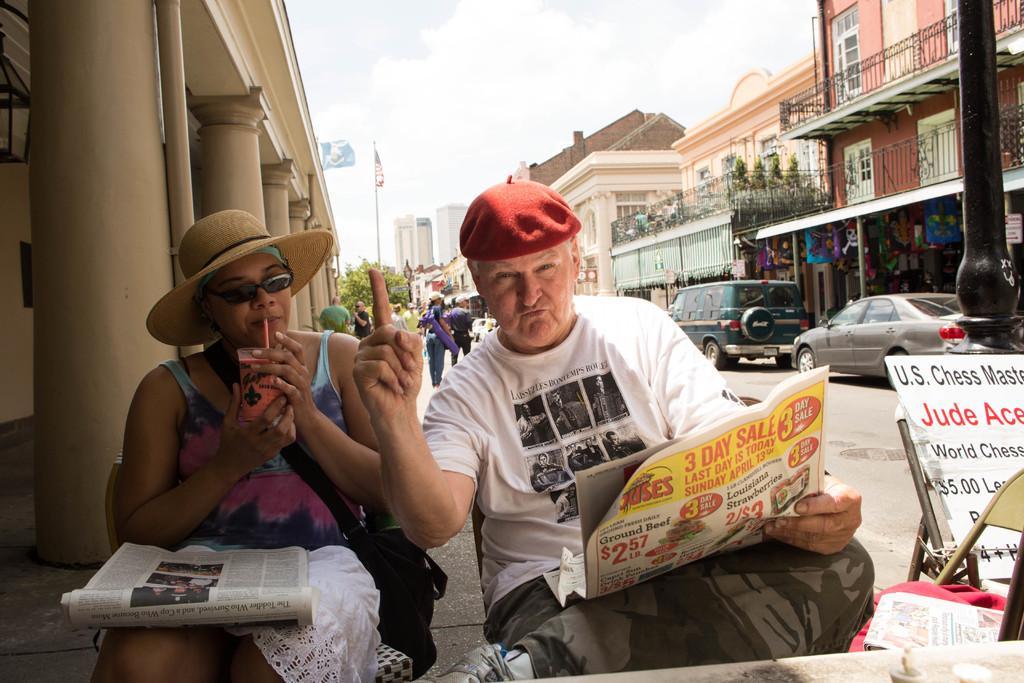Could you give a brief overview of what you see in this image? In this picture there is a old man wearing a white t--shirt, red cap, holding a newspaper and giving a pose into the camera. Beside there is a woman wearing pink color top and holding a glass juice in the hand. Behind we can see the yellow color building with many pillars. ON the right side there are some houses and cars are parked in front of the houses. 